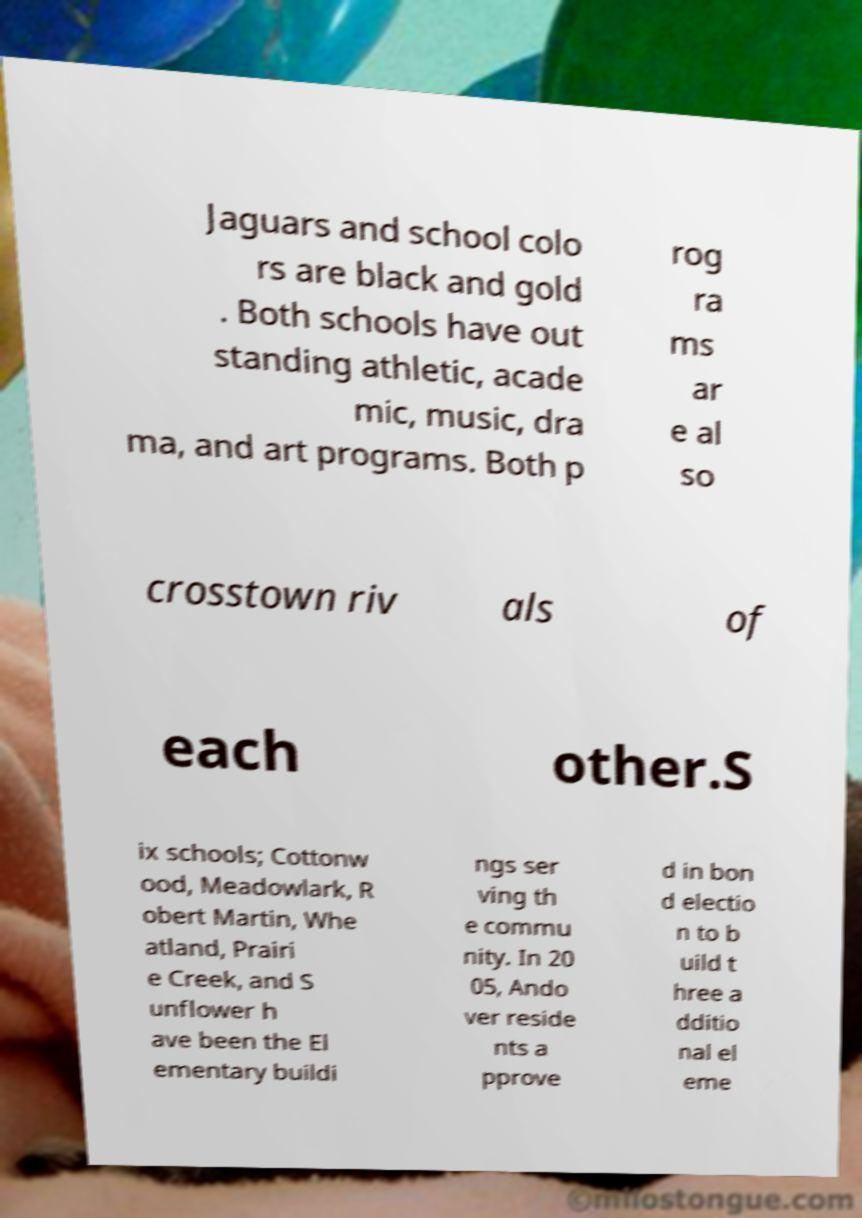Can you accurately transcribe the text from the provided image for me? Jaguars and school colo rs are black and gold . Both schools have out standing athletic, acade mic, music, dra ma, and art programs. Both p rog ra ms ar e al so crosstown riv als of each other.S ix schools; Cottonw ood, Meadowlark, R obert Martin, Whe atland, Prairi e Creek, and S unflower h ave been the El ementary buildi ngs ser ving th e commu nity. In 20 05, Ando ver reside nts a pprove d in bon d electio n to b uild t hree a dditio nal el eme 